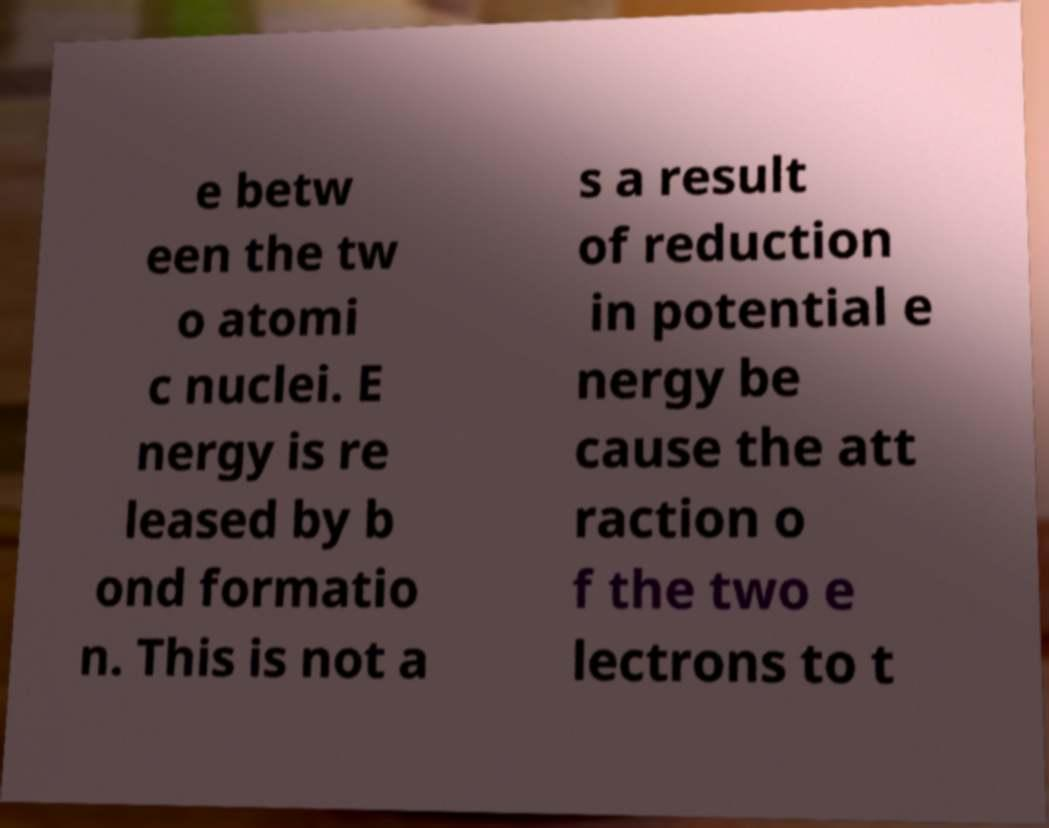Please read and relay the text visible in this image. What does it say? e betw een the tw o atomi c nuclei. E nergy is re leased by b ond formatio n. This is not a s a result of reduction in potential e nergy be cause the att raction o f the two e lectrons to t 